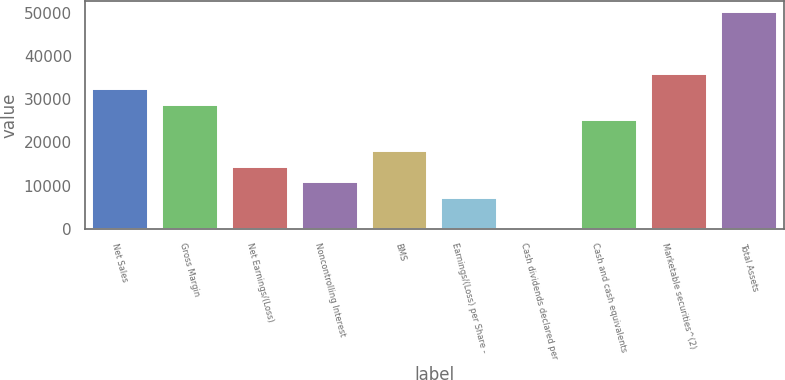Convert chart. <chart><loc_0><loc_0><loc_500><loc_500><bar_chart><fcel>Net Sales<fcel>Gross Margin<fcel>Net Earnings/(Loss)<fcel>Noncontrolling Interest<fcel>BMS<fcel>Earnings/(Loss) per Share -<fcel>Cash dividends declared per<fcel>Cash and cash equivalents<fcel>Marketable securities^(2)<fcel>Total Assets<nl><fcel>32307.3<fcel>28717.7<fcel>14359<fcel>10769.4<fcel>17948.7<fcel>7179.69<fcel>0.35<fcel>25128<fcel>35897<fcel>50255.7<nl></chart> 